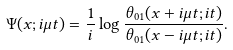<formula> <loc_0><loc_0><loc_500><loc_500>\Psi ( x ; i \mu t ) = \frac { 1 } { i } \log \frac { \theta _ { 0 1 } ( x + i \mu t ; i t ) } { \theta _ { 0 1 } ( x - i \mu t ; i t ) } .</formula> 